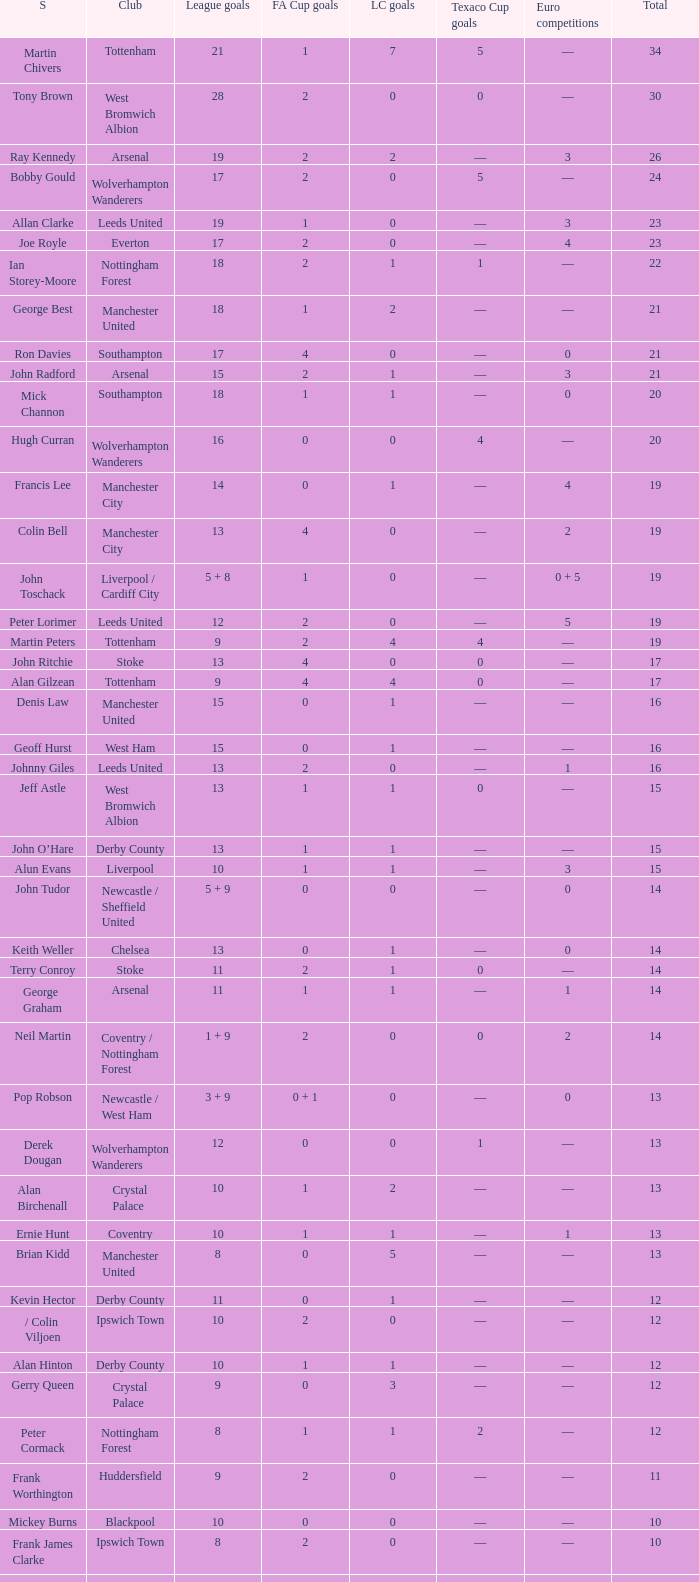What is the average Total, when FA Cup Goals is 1, when League Goals is 10, and when Club is Crystal Palace? 13.0. 